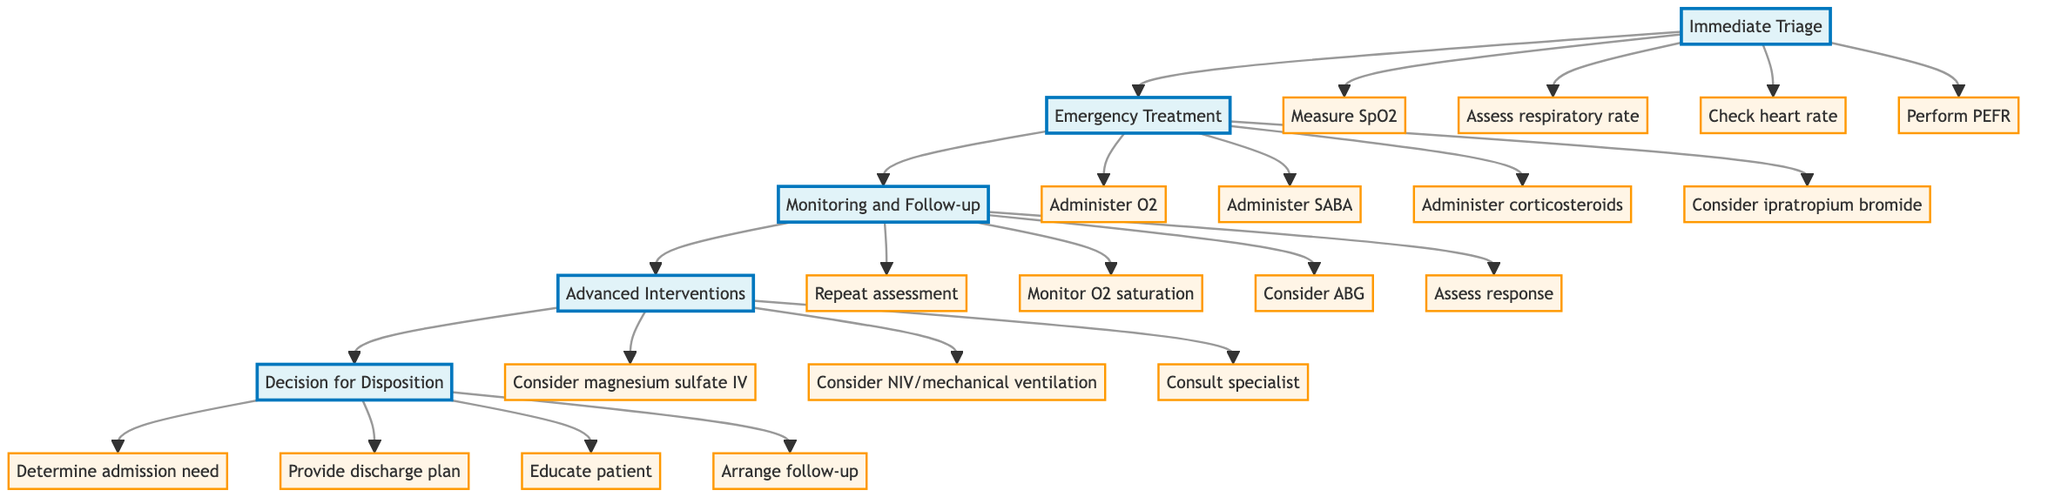What is the first step in the clinical pathway? The first step listed in the diagram is "Immediate Triage," which outlines initial actions to be taken.
Answer: Immediate Triage How many actions are listed under Emergency Treatment? There are four actions enumerated under the "Emergency Treatment" step in the diagram.
Answer: 4 What action should be taken to assess respiratory conditions? "Perform PEFR" is the action specifically aimed at assessing respiratory conditions in the initial assessment steps.
Answer: Perform PEFR What continuous monitoring action is required during Monitoring and Follow-up? The action "Monitor oxygen saturation continuously" indicates that constant monitoring of oxygen levels is required during this stage.
Answer: Monitor oxygen saturation continuously What is the second action listed under Advanced Interventions? The second action under Advanced Interventions is "Consider non-invasive ventilation (NIV) or mechanical ventilation in case of respiratory failure."
Answer: Consider non-invasive ventilation (NIV) or mechanical ventilation If there is no improvement after advanced interventions, what should be done? The diagram indicates to "Consult respiratory specialist if no improvement," which is the action taken in case of continued issues despite advanced interventions.
Answer: Consult respiratory specialist What step follows Emergency Treatment in the clinical pathway? The step that follows "Emergency Treatment" is "Monitoring and Follow-up," which entails observing the patient after the initial treatment.
Answer: Monitoring and Follow-up How often should assessments be repeated during Monitoring and Follow-up? The diagram specifies that assessments should be repeated every 20 minutes during the monitoring phase.
Answer: Every 20 minutes What is necessary to determine before a patient's discharge? It is necessary to "Determine need for hospital admission based on response to treatment" before considering discharge.
Answer: Determine need for hospital admission 